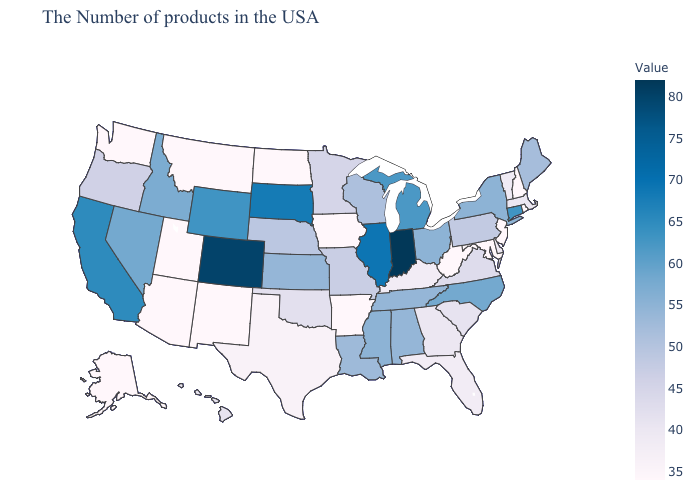Which states have the lowest value in the MidWest?
Short answer required. Iowa, North Dakota. Does West Virginia have a lower value than South Carolina?
Be succinct. Yes. Does Hawaii have the lowest value in the West?
Concise answer only. No. Does California have the highest value in the West?
Keep it brief. No. Among the states that border Maine , which have the lowest value?
Quick response, please. New Hampshire. Which states have the lowest value in the USA?
Answer briefly. Rhode Island, New Hampshire, New Jersey, Maryland, West Virginia, Arkansas, Iowa, North Dakota, New Mexico, Utah, Montana, Arizona, Washington, Alaska. 